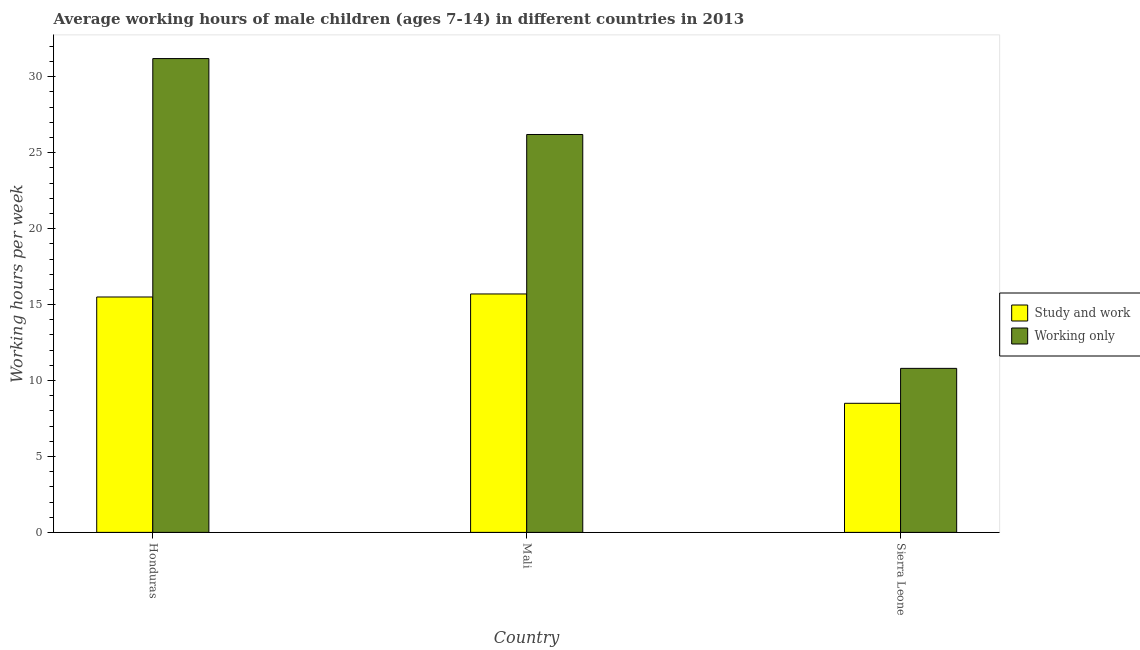How many groups of bars are there?
Offer a terse response. 3. Are the number of bars per tick equal to the number of legend labels?
Offer a very short reply. Yes. Are the number of bars on each tick of the X-axis equal?
Offer a terse response. Yes. How many bars are there on the 1st tick from the right?
Keep it short and to the point. 2. What is the label of the 2nd group of bars from the left?
Provide a succinct answer. Mali. In how many cases, is the number of bars for a given country not equal to the number of legend labels?
Keep it short and to the point. 0. In which country was the average working hour of children involved in study and work maximum?
Your response must be concise. Mali. In which country was the average working hour of children involved in only work minimum?
Your answer should be compact. Sierra Leone. What is the total average working hour of children involved in study and work in the graph?
Offer a very short reply. 39.7. What is the difference between the average working hour of children involved in study and work in Honduras and that in Sierra Leone?
Provide a succinct answer. 7. What is the difference between the average working hour of children involved in study and work in Sierra Leone and the average working hour of children involved in only work in Mali?
Your answer should be compact. -17.7. What is the average average working hour of children involved in study and work per country?
Offer a very short reply. 13.23. What is the difference between the average working hour of children involved in study and work and average working hour of children involved in only work in Honduras?
Offer a very short reply. -15.7. In how many countries, is the average working hour of children involved in study and work greater than 3 hours?
Give a very brief answer. 3. What is the ratio of the average working hour of children involved in study and work in Honduras to that in Sierra Leone?
Ensure brevity in your answer.  1.82. Is the average working hour of children involved in study and work in Mali less than that in Sierra Leone?
Provide a succinct answer. No. Is the difference between the average working hour of children involved in only work in Honduras and Sierra Leone greater than the difference between the average working hour of children involved in study and work in Honduras and Sierra Leone?
Ensure brevity in your answer.  Yes. What is the difference between the highest and the second highest average working hour of children involved in study and work?
Your response must be concise. 0.2. What is the difference between the highest and the lowest average working hour of children involved in study and work?
Give a very brief answer. 7.2. In how many countries, is the average working hour of children involved in study and work greater than the average average working hour of children involved in study and work taken over all countries?
Offer a very short reply. 2. Is the sum of the average working hour of children involved in study and work in Honduras and Mali greater than the maximum average working hour of children involved in only work across all countries?
Keep it short and to the point. No. What does the 1st bar from the left in Sierra Leone represents?
Offer a very short reply. Study and work. What does the 2nd bar from the right in Honduras represents?
Make the answer very short. Study and work. How many bars are there?
Ensure brevity in your answer.  6. How many countries are there in the graph?
Offer a terse response. 3. What is the difference between two consecutive major ticks on the Y-axis?
Your answer should be very brief. 5. How many legend labels are there?
Provide a short and direct response. 2. What is the title of the graph?
Your response must be concise. Average working hours of male children (ages 7-14) in different countries in 2013. What is the label or title of the Y-axis?
Your answer should be very brief. Working hours per week. What is the Working hours per week of Study and work in Honduras?
Provide a short and direct response. 15.5. What is the Working hours per week of Working only in Honduras?
Offer a very short reply. 31.2. What is the Working hours per week of Working only in Mali?
Provide a succinct answer. 26.2. What is the Working hours per week in Study and work in Sierra Leone?
Provide a short and direct response. 8.5. Across all countries, what is the maximum Working hours per week in Working only?
Make the answer very short. 31.2. What is the total Working hours per week of Study and work in the graph?
Make the answer very short. 39.7. What is the total Working hours per week of Working only in the graph?
Provide a short and direct response. 68.2. What is the difference between the Working hours per week in Study and work in Honduras and that in Mali?
Your response must be concise. -0.2. What is the difference between the Working hours per week of Working only in Honduras and that in Sierra Leone?
Your answer should be very brief. 20.4. What is the difference between the Working hours per week in Study and work in Mali and that in Sierra Leone?
Make the answer very short. 7.2. What is the difference between the Working hours per week in Study and work in Honduras and the Working hours per week in Working only in Mali?
Make the answer very short. -10.7. What is the difference between the Working hours per week in Study and work in Mali and the Working hours per week in Working only in Sierra Leone?
Your response must be concise. 4.9. What is the average Working hours per week in Study and work per country?
Your answer should be compact. 13.23. What is the average Working hours per week of Working only per country?
Provide a succinct answer. 22.73. What is the difference between the Working hours per week in Study and work and Working hours per week in Working only in Honduras?
Offer a terse response. -15.7. What is the difference between the Working hours per week in Study and work and Working hours per week in Working only in Mali?
Your response must be concise. -10.5. What is the difference between the Working hours per week of Study and work and Working hours per week of Working only in Sierra Leone?
Make the answer very short. -2.3. What is the ratio of the Working hours per week in Study and work in Honduras to that in Mali?
Provide a succinct answer. 0.99. What is the ratio of the Working hours per week of Working only in Honduras to that in Mali?
Your answer should be very brief. 1.19. What is the ratio of the Working hours per week in Study and work in Honduras to that in Sierra Leone?
Give a very brief answer. 1.82. What is the ratio of the Working hours per week in Working only in Honduras to that in Sierra Leone?
Give a very brief answer. 2.89. What is the ratio of the Working hours per week in Study and work in Mali to that in Sierra Leone?
Your answer should be compact. 1.85. What is the ratio of the Working hours per week of Working only in Mali to that in Sierra Leone?
Give a very brief answer. 2.43. What is the difference between the highest and the second highest Working hours per week of Study and work?
Give a very brief answer. 0.2. What is the difference between the highest and the lowest Working hours per week in Study and work?
Make the answer very short. 7.2. What is the difference between the highest and the lowest Working hours per week in Working only?
Offer a terse response. 20.4. 